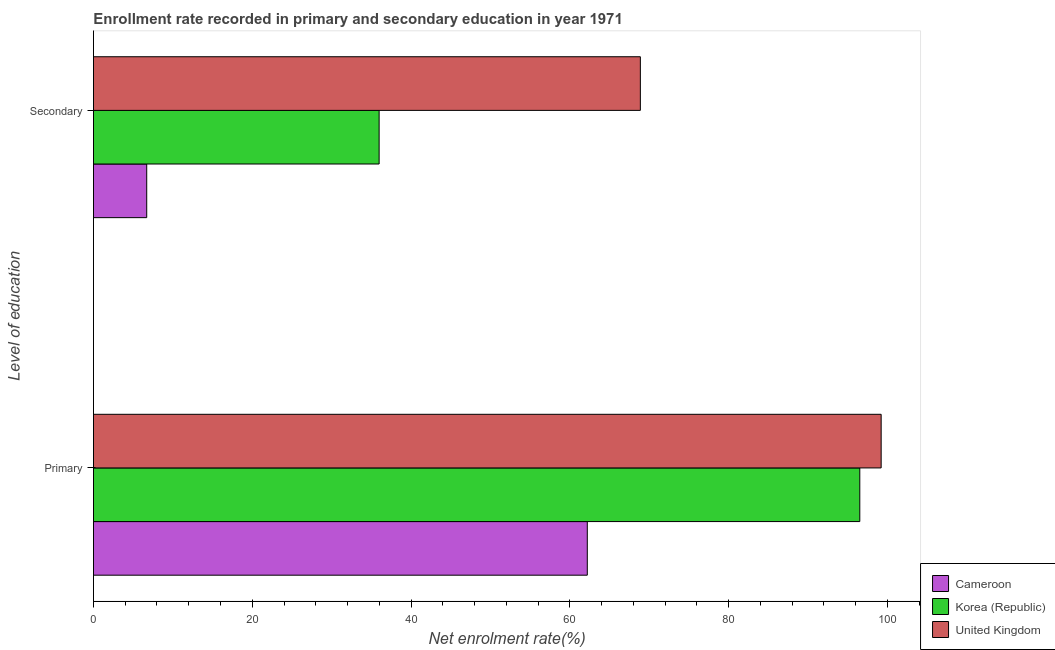How many different coloured bars are there?
Make the answer very short. 3. How many groups of bars are there?
Ensure brevity in your answer.  2. Are the number of bars on each tick of the Y-axis equal?
Your answer should be compact. Yes. What is the label of the 2nd group of bars from the top?
Your response must be concise. Primary. What is the enrollment rate in secondary education in United Kingdom?
Offer a very short reply. 68.88. Across all countries, what is the maximum enrollment rate in secondary education?
Your answer should be compact. 68.88. Across all countries, what is the minimum enrollment rate in primary education?
Provide a short and direct response. 62.2. In which country was the enrollment rate in primary education maximum?
Offer a very short reply. United Kingdom. In which country was the enrollment rate in primary education minimum?
Your answer should be compact. Cameroon. What is the total enrollment rate in primary education in the graph?
Provide a short and direct response. 257.92. What is the difference between the enrollment rate in primary education in Korea (Republic) and that in United Kingdom?
Ensure brevity in your answer.  -2.69. What is the difference between the enrollment rate in secondary education in United Kingdom and the enrollment rate in primary education in Korea (Republic)?
Give a very brief answer. -27.64. What is the average enrollment rate in secondary education per country?
Provide a succinct answer. 37.19. What is the difference between the enrollment rate in secondary education and enrollment rate in primary education in United Kingdom?
Your answer should be compact. -30.33. What is the ratio of the enrollment rate in primary education in United Kingdom to that in Cameroon?
Keep it short and to the point. 1.6. What does the 1st bar from the bottom in Primary represents?
Give a very brief answer. Cameroon. How many bars are there?
Your answer should be very brief. 6. Does the graph contain any zero values?
Ensure brevity in your answer.  No. Does the graph contain grids?
Offer a very short reply. No. Where does the legend appear in the graph?
Offer a terse response. Bottom right. How many legend labels are there?
Offer a terse response. 3. How are the legend labels stacked?
Keep it short and to the point. Vertical. What is the title of the graph?
Keep it short and to the point. Enrollment rate recorded in primary and secondary education in year 1971. Does "Arab World" appear as one of the legend labels in the graph?
Keep it short and to the point. No. What is the label or title of the X-axis?
Offer a very short reply. Net enrolment rate(%). What is the label or title of the Y-axis?
Ensure brevity in your answer.  Level of education. What is the Net enrolment rate(%) of Cameroon in Primary?
Your response must be concise. 62.2. What is the Net enrolment rate(%) of Korea (Republic) in Primary?
Your answer should be compact. 96.52. What is the Net enrolment rate(%) in United Kingdom in Primary?
Your response must be concise. 99.21. What is the Net enrolment rate(%) of Cameroon in Secondary?
Your answer should be very brief. 6.71. What is the Net enrolment rate(%) of Korea (Republic) in Secondary?
Offer a very short reply. 35.98. What is the Net enrolment rate(%) of United Kingdom in Secondary?
Ensure brevity in your answer.  68.88. Across all Level of education, what is the maximum Net enrolment rate(%) in Cameroon?
Your answer should be compact. 62.2. Across all Level of education, what is the maximum Net enrolment rate(%) in Korea (Republic)?
Offer a very short reply. 96.52. Across all Level of education, what is the maximum Net enrolment rate(%) of United Kingdom?
Keep it short and to the point. 99.21. Across all Level of education, what is the minimum Net enrolment rate(%) of Cameroon?
Provide a short and direct response. 6.71. Across all Level of education, what is the minimum Net enrolment rate(%) in Korea (Republic)?
Provide a succinct answer. 35.98. Across all Level of education, what is the minimum Net enrolment rate(%) of United Kingdom?
Your response must be concise. 68.88. What is the total Net enrolment rate(%) in Cameroon in the graph?
Offer a very short reply. 68.9. What is the total Net enrolment rate(%) of Korea (Republic) in the graph?
Provide a succinct answer. 132.49. What is the total Net enrolment rate(%) in United Kingdom in the graph?
Provide a succinct answer. 168.08. What is the difference between the Net enrolment rate(%) in Cameroon in Primary and that in Secondary?
Your answer should be compact. 55.49. What is the difference between the Net enrolment rate(%) of Korea (Republic) in Primary and that in Secondary?
Keep it short and to the point. 60.54. What is the difference between the Net enrolment rate(%) in United Kingdom in Primary and that in Secondary?
Your answer should be very brief. 30.33. What is the difference between the Net enrolment rate(%) in Cameroon in Primary and the Net enrolment rate(%) in Korea (Republic) in Secondary?
Your answer should be compact. 26.22. What is the difference between the Net enrolment rate(%) of Cameroon in Primary and the Net enrolment rate(%) of United Kingdom in Secondary?
Keep it short and to the point. -6.68. What is the difference between the Net enrolment rate(%) in Korea (Republic) in Primary and the Net enrolment rate(%) in United Kingdom in Secondary?
Offer a terse response. 27.64. What is the average Net enrolment rate(%) in Cameroon per Level of education?
Your response must be concise. 34.45. What is the average Net enrolment rate(%) in Korea (Republic) per Level of education?
Your answer should be compact. 66.25. What is the average Net enrolment rate(%) of United Kingdom per Level of education?
Provide a succinct answer. 84.04. What is the difference between the Net enrolment rate(%) of Cameroon and Net enrolment rate(%) of Korea (Republic) in Primary?
Provide a succinct answer. -34.32. What is the difference between the Net enrolment rate(%) in Cameroon and Net enrolment rate(%) in United Kingdom in Primary?
Keep it short and to the point. -37.01. What is the difference between the Net enrolment rate(%) of Korea (Republic) and Net enrolment rate(%) of United Kingdom in Primary?
Offer a terse response. -2.69. What is the difference between the Net enrolment rate(%) in Cameroon and Net enrolment rate(%) in Korea (Republic) in Secondary?
Provide a succinct answer. -29.27. What is the difference between the Net enrolment rate(%) in Cameroon and Net enrolment rate(%) in United Kingdom in Secondary?
Provide a succinct answer. -62.17. What is the difference between the Net enrolment rate(%) in Korea (Republic) and Net enrolment rate(%) in United Kingdom in Secondary?
Offer a terse response. -32.9. What is the ratio of the Net enrolment rate(%) of Cameroon in Primary to that in Secondary?
Provide a short and direct response. 9.27. What is the ratio of the Net enrolment rate(%) in Korea (Republic) in Primary to that in Secondary?
Provide a short and direct response. 2.68. What is the ratio of the Net enrolment rate(%) in United Kingdom in Primary to that in Secondary?
Your response must be concise. 1.44. What is the difference between the highest and the second highest Net enrolment rate(%) of Cameroon?
Provide a succinct answer. 55.49. What is the difference between the highest and the second highest Net enrolment rate(%) in Korea (Republic)?
Give a very brief answer. 60.54. What is the difference between the highest and the second highest Net enrolment rate(%) of United Kingdom?
Offer a very short reply. 30.33. What is the difference between the highest and the lowest Net enrolment rate(%) in Cameroon?
Your response must be concise. 55.49. What is the difference between the highest and the lowest Net enrolment rate(%) in Korea (Republic)?
Offer a very short reply. 60.54. What is the difference between the highest and the lowest Net enrolment rate(%) in United Kingdom?
Keep it short and to the point. 30.33. 